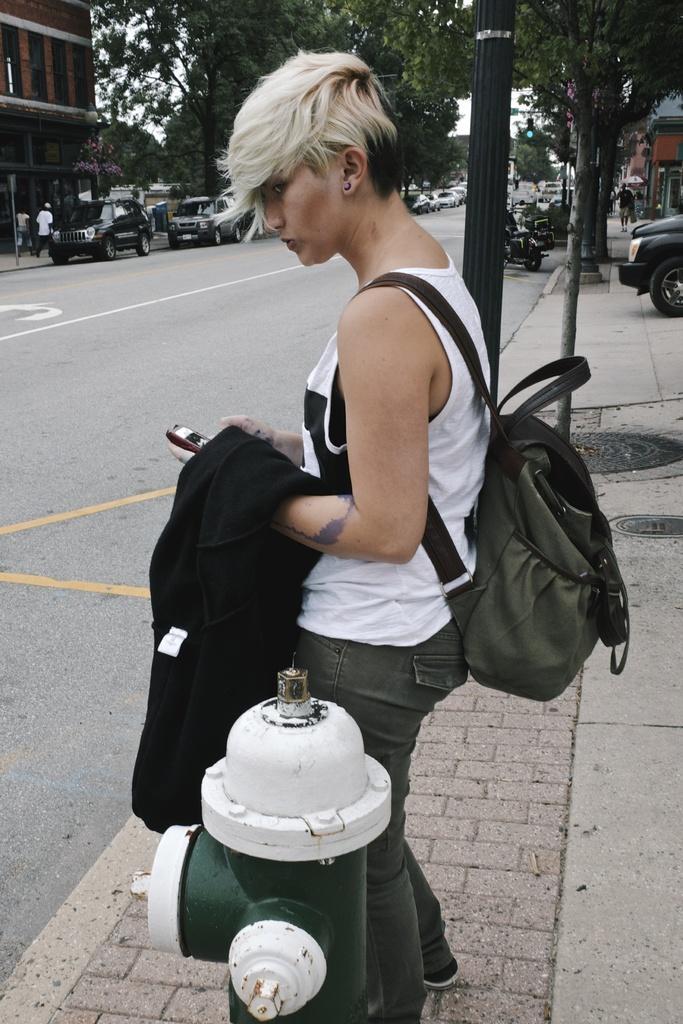Describe this image in one or two sentences. In this picture there are buildings and trees. In the foreground there is a woman standing and holding the phone and there is a fire hydrant. At the back there are vehicles on the road and there are three people walking on the footpath and there are street lights. At the top there is sky. At the bottom there is a road. 